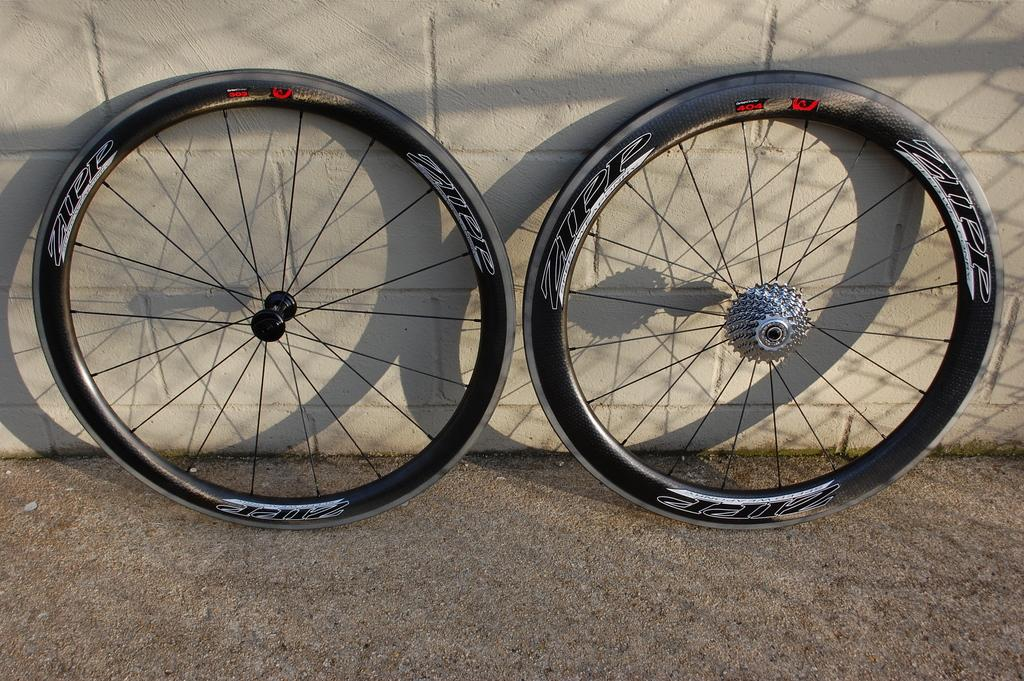What objects are present in the image that have wheels? There are two wheels in the image. What can be seen in the background of the image? There is a wall in the background of the image. What type of market is being developed near the wall in the image? There is no mention of a market or development in the image; it only features two wheels and a wall in the background. 